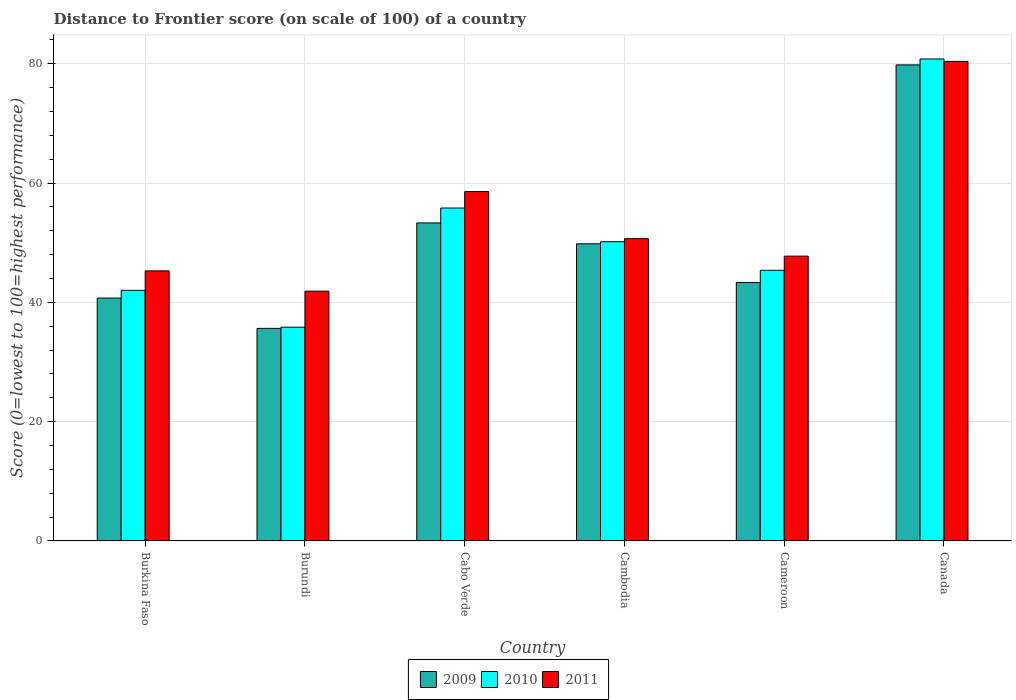How many groups of bars are there?
Your answer should be very brief. 6. Are the number of bars on each tick of the X-axis equal?
Your answer should be very brief. Yes. What is the label of the 1st group of bars from the left?
Keep it short and to the point. Burkina Faso. What is the distance to frontier score of in 2010 in Canada?
Your answer should be very brief. 80.81. Across all countries, what is the maximum distance to frontier score of in 2010?
Your answer should be compact. 80.81. Across all countries, what is the minimum distance to frontier score of in 2009?
Provide a short and direct response. 35.64. In which country was the distance to frontier score of in 2010 minimum?
Provide a succinct answer. Burundi. What is the total distance to frontier score of in 2011 in the graph?
Your answer should be compact. 324.57. What is the difference between the distance to frontier score of in 2011 in Cabo Verde and that in Canada?
Provide a short and direct response. -21.82. What is the difference between the distance to frontier score of in 2009 in Burkina Faso and the distance to frontier score of in 2010 in Cambodia?
Your answer should be compact. -9.45. What is the average distance to frontier score of in 2009 per country?
Your answer should be compact. 50.44. What is the difference between the distance to frontier score of of/in 2011 and distance to frontier score of of/in 2010 in Cabo Verde?
Your answer should be very brief. 2.76. What is the ratio of the distance to frontier score of in 2011 in Burkina Faso to that in Burundi?
Your response must be concise. 1.08. What is the difference between the highest and the second highest distance to frontier score of in 2011?
Your answer should be compact. 21.82. What is the difference between the highest and the lowest distance to frontier score of in 2010?
Your answer should be compact. 44.97. In how many countries, is the distance to frontier score of in 2009 greater than the average distance to frontier score of in 2009 taken over all countries?
Offer a terse response. 2. Is the sum of the distance to frontier score of in 2010 in Burkina Faso and Cameroon greater than the maximum distance to frontier score of in 2011 across all countries?
Make the answer very short. Yes. What does the 3rd bar from the right in Burundi represents?
Your response must be concise. 2009. Are all the bars in the graph horizontal?
Provide a short and direct response. No. What is the difference between two consecutive major ticks on the Y-axis?
Offer a terse response. 20. Are the values on the major ticks of Y-axis written in scientific E-notation?
Offer a terse response. No. Does the graph contain grids?
Keep it short and to the point. Yes. How are the legend labels stacked?
Keep it short and to the point. Horizontal. What is the title of the graph?
Make the answer very short. Distance to Frontier score (on scale of 100) of a country. Does "1992" appear as one of the legend labels in the graph?
Provide a short and direct response. No. What is the label or title of the Y-axis?
Keep it short and to the point. Score (0=lowest to 100=highest performance). What is the Score (0=lowest to 100=highest performance) in 2009 in Burkina Faso?
Your answer should be compact. 40.72. What is the Score (0=lowest to 100=highest performance) of 2010 in Burkina Faso?
Ensure brevity in your answer.  42.02. What is the Score (0=lowest to 100=highest performance) of 2011 in Burkina Faso?
Keep it short and to the point. 45.28. What is the Score (0=lowest to 100=highest performance) in 2009 in Burundi?
Your answer should be very brief. 35.64. What is the Score (0=lowest to 100=highest performance) of 2010 in Burundi?
Your response must be concise. 35.84. What is the Score (0=lowest to 100=highest performance) of 2011 in Burundi?
Offer a terse response. 41.88. What is the Score (0=lowest to 100=highest performance) in 2009 in Cabo Verde?
Give a very brief answer. 53.32. What is the Score (0=lowest to 100=highest performance) of 2010 in Cabo Verde?
Your answer should be very brief. 55.82. What is the Score (0=lowest to 100=highest performance) in 2011 in Cabo Verde?
Your answer should be compact. 58.58. What is the Score (0=lowest to 100=highest performance) of 2009 in Cambodia?
Keep it short and to the point. 49.82. What is the Score (0=lowest to 100=highest performance) of 2010 in Cambodia?
Offer a terse response. 50.17. What is the Score (0=lowest to 100=highest performance) of 2011 in Cambodia?
Your answer should be very brief. 50.68. What is the Score (0=lowest to 100=highest performance) in 2009 in Cameroon?
Provide a succinct answer. 43.33. What is the Score (0=lowest to 100=highest performance) in 2010 in Cameroon?
Ensure brevity in your answer.  45.38. What is the Score (0=lowest to 100=highest performance) in 2011 in Cameroon?
Offer a very short reply. 47.75. What is the Score (0=lowest to 100=highest performance) in 2009 in Canada?
Give a very brief answer. 79.82. What is the Score (0=lowest to 100=highest performance) of 2010 in Canada?
Provide a succinct answer. 80.81. What is the Score (0=lowest to 100=highest performance) in 2011 in Canada?
Provide a short and direct response. 80.4. Across all countries, what is the maximum Score (0=lowest to 100=highest performance) of 2009?
Give a very brief answer. 79.82. Across all countries, what is the maximum Score (0=lowest to 100=highest performance) in 2010?
Your answer should be compact. 80.81. Across all countries, what is the maximum Score (0=lowest to 100=highest performance) in 2011?
Give a very brief answer. 80.4. Across all countries, what is the minimum Score (0=lowest to 100=highest performance) in 2009?
Provide a succinct answer. 35.64. Across all countries, what is the minimum Score (0=lowest to 100=highest performance) in 2010?
Your response must be concise. 35.84. Across all countries, what is the minimum Score (0=lowest to 100=highest performance) in 2011?
Your answer should be very brief. 41.88. What is the total Score (0=lowest to 100=highest performance) in 2009 in the graph?
Give a very brief answer. 302.65. What is the total Score (0=lowest to 100=highest performance) in 2010 in the graph?
Offer a very short reply. 310.04. What is the total Score (0=lowest to 100=highest performance) in 2011 in the graph?
Offer a terse response. 324.57. What is the difference between the Score (0=lowest to 100=highest performance) in 2009 in Burkina Faso and that in Burundi?
Give a very brief answer. 5.08. What is the difference between the Score (0=lowest to 100=highest performance) in 2010 in Burkina Faso and that in Burundi?
Your answer should be very brief. 6.18. What is the difference between the Score (0=lowest to 100=highest performance) of 2009 in Burkina Faso and that in Cambodia?
Keep it short and to the point. -9.1. What is the difference between the Score (0=lowest to 100=highest performance) of 2010 in Burkina Faso and that in Cambodia?
Provide a succinct answer. -8.15. What is the difference between the Score (0=lowest to 100=highest performance) in 2011 in Burkina Faso and that in Cambodia?
Keep it short and to the point. -5.4. What is the difference between the Score (0=lowest to 100=highest performance) in 2009 in Burkina Faso and that in Cameroon?
Ensure brevity in your answer.  -2.61. What is the difference between the Score (0=lowest to 100=highest performance) in 2010 in Burkina Faso and that in Cameroon?
Make the answer very short. -3.36. What is the difference between the Score (0=lowest to 100=highest performance) in 2011 in Burkina Faso and that in Cameroon?
Your answer should be very brief. -2.47. What is the difference between the Score (0=lowest to 100=highest performance) in 2009 in Burkina Faso and that in Canada?
Keep it short and to the point. -39.1. What is the difference between the Score (0=lowest to 100=highest performance) in 2010 in Burkina Faso and that in Canada?
Give a very brief answer. -38.79. What is the difference between the Score (0=lowest to 100=highest performance) in 2011 in Burkina Faso and that in Canada?
Your answer should be compact. -35.12. What is the difference between the Score (0=lowest to 100=highest performance) in 2009 in Burundi and that in Cabo Verde?
Provide a short and direct response. -17.68. What is the difference between the Score (0=lowest to 100=highest performance) in 2010 in Burundi and that in Cabo Verde?
Ensure brevity in your answer.  -19.98. What is the difference between the Score (0=lowest to 100=highest performance) in 2011 in Burundi and that in Cabo Verde?
Your response must be concise. -16.7. What is the difference between the Score (0=lowest to 100=highest performance) of 2009 in Burundi and that in Cambodia?
Ensure brevity in your answer.  -14.18. What is the difference between the Score (0=lowest to 100=highest performance) of 2010 in Burundi and that in Cambodia?
Your answer should be compact. -14.33. What is the difference between the Score (0=lowest to 100=highest performance) of 2011 in Burundi and that in Cambodia?
Your answer should be very brief. -8.8. What is the difference between the Score (0=lowest to 100=highest performance) in 2009 in Burundi and that in Cameroon?
Offer a terse response. -7.69. What is the difference between the Score (0=lowest to 100=highest performance) in 2010 in Burundi and that in Cameroon?
Your answer should be very brief. -9.54. What is the difference between the Score (0=lowest to 100=highest performance) of 2011 in Burundi and that in Cameroon?
Offer a very short reply. -5.87. What is the difference between the Score (0=lowest to 100=highest performance) in 2009 in Burundi and that in Canada?
Give a very brief answer. -44.18. What is the difference between the Score (0=lowest to 100=highest performance) in 2010 in Burundi and that in Canada?
Your response must be concise. -44.97. What is the difference between the Score (0=lowest to 100=highest performance) in 2011 in Burundi and that in Canada?
Give a very brief answer. -38.52. What is the difference between the Score (0=lowest to 100=highest performance) of 2009 in Cabo Verde and that in Cambodia?
Your response must be concise. 3.5. What is the difference between the Score (0=lowest to 100=highest performance) of 2010 in Cabo Verde and that in Cambodia?
Offer a terse response. 5.65. What is the difference between the Score (0=lowest to 100=highest performance) of 2011 in Cabo Verde and that in Cambodia?
Your response must be concise. 7.9. What is the difference between the Score (0=lowest to 100=highest performance) of 2009 in Cabo Verde and that in Cameroon?
Ensure brevity in your answer.  9.99. What is the difference between the Score (0=lowest to 100=highest performance) in 2010 in Cabo Verde and that in Cameroon?
Make the answer very short. 10.44. What is the difference between the Score (0=lowest to 100=highest performance) of 2011 in Cabo Verde and that in Cameroon?
Your response must be concise. 10.83. What is the difference between the Score (0=lowest to 100=highest performance) in 2009 in Cabo Verde and that in Canada?
Your response must be concise. -26.5. What is the difference between the Score (0=lowest to 100=highest performance) in 2010 in Cabo Verde and that in Canada?
Keep it short and to the point. -24.99. What is the difference between the Score (0=lowest to 100=highest performance) of 2011 in Cabo Verde and that in Canada?
Your response must be concise. -21.82. What is the difference between the Score (0=lowest to 100=highest performance) in 2009 in Cambodia and that in Cameroon?
Give a very brief answer. 6.49. What is the difference between the Score (0=lowest to 100=highest performance) in 2010 in Cambodia and that in Cameroon?
Your answer should be very brief. 4.79. What is the difference between the Score (0=lowest to 100=highest performance) in 2011 in Cambodia and that in Cameroon?
Offer a very short reply. 2.93. What is the difference between the Score (0=lowest to 100=highest performance) in 2009 in Cambodia and that in Canada?
Make the answer very short. -30. What is the difference between the Score (0=lowest to 100=highest performance) in 2010 in Cambodia and that in Canada?
Make the answer very short. -30.64. What is the difference between the Score (0=lowest to 100=highest performance) in 2011 in Cambodia and that in Canada?
Offer a very short reply. -29.72. What is the difference between the Score (0=lowest to 100=highest performance) of 2009 in Cameroon and that in Canada?
Offer a terse response. -36.49. What is the difference between the Score (0=lowest to 100=highest performance) in 2010 in Cameroon and that in Canada?
Your answer should be compact. -35.43. What is the difference between the Score (0=lowest to 100=highest performance) of 2011 in Cameroon and that in Canada?
Ensure brevity in your answer.  -32.65. What is the difference between the Score (0=lowest to 100=highest performance) in 2009 in Burkina Faso and the Score (0=lowest to 100=highest performance) in 2010 in Burundi?
Give a very brief answer. 4.88. What is the difference between the Score (0=lowest to 100=highest performance) in 2009 in Burkina Faso and the Score (0=lowest to 100=highest performance) in 2011 in Burundi?
Keep it short and to the point. -1.16. What is the difference between the Score (0=lowest to 100=highest performance) of 2010 in Burkina Faso and the Score (0=lowest to 100=highest performance) of 2011 in Burundi?
Provide a short and direct response. 0.14. What is the difference between the Score (0=lowest to 100=highest performance) in 2009 in Burkina Faso and the Score (0=lowest to 100=highest performance) in 2010 in Cabo Verde?
Offer a very short reply. -15.1. What is the difference between the Score (0=lowest to 100=highest performance) in 2009 in Burkina Faso and the Score (0=lowest to 100=highest performance) in 2011 in Cabo Verde?
Your answer should be very brief. -17.86. What is the difference between the Score (0=lowest to 100=highest performance) in 2010 in Burkina Faso and the Score (0=lowest to 100=highest performance) in 2011 in Cabo Verde?
Offer a terse response. -16.56. What is the difference between the Score (0=lowest to 100=highest performance) in 2009 in Burkina Faso and the Score (0=lowest to 100=highest performance) in 2010 in Cambodia?
Keep it short and to the point. -9.45. What is the difference between the Score (0=lowest to 100=highest performance) of 2009 in Burkina Faso and the Score (0=lowest to 100=highest performance) of 2011 in Cambodia?
Make the answer very short. -9.96. What is the difference between the Score (0=lowest to 100=highest performance) in 2010 in Burkina Faso and the Score (0=lowest to 100=highest performance) in 2011 in Cambodia?
Your answer should be compact. -8.66. What is the difference between the Score (0=lowest to 100=highest performance) in 2009 in Burkina Faso and the Score (0=lowest to 100=highest performance) in 2010 in Cameroon?
Provide a succinct answer. -4.66. What is the difference between the Score (0=lowest to 100=highest performance) in 2009 in Burkina Faso and the Score (0=lowest to 100=highest performance) in 2011 in Cameroon?
Offer a terse response. -7.03. What is the difference between the Score (0=lowest to 100=highest performance) in 2010 in Burkina Faso and the Score (0=lowest to 100=highest performance) in 2011 in Cameroon?
Give a very brief answer. -5.73. What is the difference between the Score (0=lowest to 100=highest performance) of 2009 in Burkina Faso and the Score (0=lowest to 100=highest performance) of 2010 in Canada?
Offer a very short reply. -40.09. What is the difference between the Score (0=lowest to 100=highest performance) of 2009 in Burkina Faso and the Score (0=lowest to 100=highest performance) of 2011 in Canada?
Provide a succinct answer. -39.68. What is the difference between the Score (0=lowest to 100=highest performance) in 2010 in Burkina Faso and the Score (0=lowest to 100=highest performance) in 2011 in Canada?
Ensure brevity in your answer.  -38.38. What is the difference between the Score (0=lowest to 100=highest performance) in 2009 in Burundi and the Score (0=lowest to 100=highest performance) in 2010 in Cabo Verde?
Keep it short and to the point. -20.18. What is the difference between the Score (0=lowest to 100=highest performance) in 2009 in Burundi and the Score (0=lowest to 100=highest performance) in 2011 in Cabo Verde?
Your answer should be very brief. -22.94. What is the difference between the Score (0=lowest to 100=highest performance) of 2010 in Burundi and the Score (0=lowest to 100=highest performance) of 2011 in Cabo Verde?
Your answer should be very brief. -22.74. What is the difference between the Score (0=lowest to 100=highest performance) in 2009 in Burundi and the Score (0=lowest to 100=highest performance) in 2010 in Cambodia?
Make the answer very short. -14.53. What is the difference between the Score (0=lowest to 100=highest performance) in 2009 in Burundi and the Score (0=lowest to 100=highest performance) in 2011 in Cambodia?
Ensure brevity in your answer.  -15.04. What is the difference between the Score (0=lowest to 100=highest performance) in 2010 in Burundi and the Score (0=lowest to 100=highest performance) in 2011 in Cambodia?
Provide a short and direct response. -14.84. What is the difference between the Score (0=lowest to 100=highest performance) of 2009 in Burundi and the Score (0=lowest to 100=highest performance) of 2010 in Cameroon?
Offer a very short reply. -9.74. What is the difference between the Score (0=lowest to 100=highest performance) of 2009 in Burundi and the Score (0=lowest to 100=highest performance) of 2011 in Cameroon?
Your answer should be very brief. -12.11. What is the difference between the Score (0=lowest to 100=highest performance) in 2010 in Burundi and the Score (0=lowest to 100=highest performance) in 2011 in Cameroon?
Offer a very short reply. -11.91. What is the difference between the Score (0=lowest to 100=highest performance) in 2009 in Burundi and the Score (0=lowest to 100=highest performance) in 2010 in Canada?
Give a very brief answer. -45.17. What is the difference between the Score (0=lowest to 100=highest performance) in 2009 in Burundi and the Score (0=lowest to 100=highest performance) in 2011 in Canada?
Keep it short and to the point. -44.76. What is the difference between the Score (0=lowest to 100=highest performance) of 2010 in Burundi and the Score (0=lowest to 100=highest performance) of 2011 in Canada?
Your response must be concise. -44.56. What is the difference between the Score (0=lowest to 100=highest performance) of 2009 in Cabo Verde and the Score (0=lowest to 100=highest performance) of 2010 in Cambodia?
Your response must be concise. 3.15. What is the difference between the Score (0=lowest to 100=highest performance) in 2009 in Cabo Verde and the Score (0=lowest to 100=highest performance) in 2011 in Cambodia?
Give a very brief answer. 2.64. What is the difference between the Score (0=lowest to 100=highest performance) of 2010 in Cabo Verde and the Score (0=lowest to 100=highest performance) of 2011 in Cambodia?
Provide a short and direct response. 5.14. What is the difference between the Score (0=lowest to 100=highest performance) of 2009 in Cabo Verde and the Score (0=lowest to 100=highest performance) of 2010 in Cameroon?
Offer a terse response. 7.94. What is the difference between the Score (0=lowest to 100=highest performance) of 2009 in Cabo Verde and the Score (0=lowest to 100=highest performance) of 2011 in Cameroon?
Make the answer very short. 5.57. What is the difference between the Score (0=lowest to 100=highest performance) in 2010 in Cabo Verde and the Score (0=lowest to 100=highest performance) in 2011 in Cameroon?
Your answer should be very brief. 8.07. What is the difference between the Score (0=lowest to 100=highest performance) in 2009 in Cabo Verde and the Score (0=lowest to 100=highest performance) in 2010 in Canada?
Your response must be concise. -27.49. What is the difference between the Score (0=lowest to 100=highest performance) of 2009 in Cabo Verde and the Score (0=lowest to 100=highest performance) of 2011 in Canada?
Your response must be concise. -27.08. What is the difference between the Score (0=lowest to 100=highest performance) of 2010 in Cabo Verde and the Score (0=lowest to 100=highest performance) of 2011 in Canada?
Give a very brief answer. -24.58. What is the difference between the Score (0=lowest to 100=highest performance) of 2009 in Cambodia and the Score (0=lowest to 100=highest performance) of 2010 in Cameroon?
Your answer should be compact. 4.44. What is the difference between the Score (0=lowest to 100=highest performance) of 2009 in Cambodia and the Score (0=lowest to 100=highest performance) of 2011 in Cameroon?
Your answer should be very brief. 2.07. What is the difference between the Score (0=lowest to 100=highest performance) of 2010 in Cambodia and the Score (0=lowest to 100=highest performance) of 2011 in Cameroon?
Ensure brevity in your answer.  2.42. What is the difference between the Score (0=lowest to 100=highest performance) in 2009 in Cambodia and the Score (0=lowest to 100=highest performance) in 2010 in Canada?
Your answer should be very brief. -30.99. What is the difference between the Score (0=lowest to 100=highest performance) of 2009 in Cambodia and the Score (0=lowest to 100=highest performance) of 2011 in Canada?
Offer a terse response. -30.58. What is the difference between the Score (0=lowest to 100=highest performance) in 2010 in Cambodia and the Score (0=lowest to 100=highest performance) in 2011 in Canada?
Provide a short and direct response. -30.23. What is the difference between the Score (0=lowest to 100=highest performance) of 2009 in Cameroon and the Score (0=lowest to 100=highest performance) of 2010 in Canada?
Your answer should be compact. -37.48. What is the difference between the Score (0=lowest to 100=highest performance) of 2009 in Cameroon and the Score (0=lowest to 100=highest performance) of 2011 in Canada?
Make the answer very short. -37.07. What is the difference between the Score (0=lowest to 100=highest performance) in 2010 in Cameroon and the Score (0=lowest to 100=highest performance) in 2011 in Canada?
Offer a very short reply. -35.02. What is the average Score (0=lowest to 100=highest performance) in 2009 per country?
Your response must be concise. 50.44. What is the average Score (0=lowest to 100=highest performance) in 2010 per country?
Ensure brevity in your answer.  51.67. What is the average Score (0=lowest to 100=highest performance) of 2011 per country?
Your answer should be compact. 54.09. What is the difference between the Score (0=lowest to 100=highest performance) of 2009 and Score (0=lowest to 100=highest performance) of 2011 in Burkina Faso?
Give a very brief answer. -4.56. What is the difference between the Score (0=lowest to 100=highest performance) of 2010 and Score (0=lowest to 100=highest performance) of 2011 in Burkina Faso?
Provide a succinct answer. -3.26. What is the difference between the Score (0=lowest to 100=highest performance) in 2009 and Score (0=lowest to 100=highest performance) in 2011 in Burundi?
Offer a terse response. -6.24. What is the difference between the Score (0=lowest to 100=highest performance) of 2010 and Score (0=lowest to 100=highest performance) of 2011 in Burundi?
Make the answer very short. -6.04. What is the difference between the Score (0=lowest to 100=highest performance) of 2009 and Score (0=lowest to 100=highest performance) of 2011 in Cabo Verde?
Your answer should be very brief. -5.26. What is the difference between the Score (0=lowest to 100=highest performance) of 2010 and Score (0=lowest to 100=highest performance) of 2011 in Cabo Verde?
Give a very brief answer. -2.76. What is the difference between the Score (0=lowest to 100=highest performance) of 2009 and Score (0=lowest to 100=highest performance) of 2010 in Cambodia?
Provide a short and direct response. -0.35. What is the difference between the Score (0=lowest to 100=highest performance) in 2009 and Score (0=lowest to 100=highest performance) in 2011 in Cambodia?
Your response must be concise. -0.86. What is the difference between the Score (0=lowest to 100=highest performance) in 2010 and Score (0=lowest to 100=highest performance) in 2011 in Cambodia?
Give a very brief answer. -0.51. What is the difference between the Score (0=lowest to 100=highest performance) of 2009 and Score (0=lowest to 100=highest performance) of 2010 in Cameroon?
Provide a short and direct response. -2.05. What is the difference between the Score (0=lowest to 100=highest performance) in 2009 and Score (0=lowest to 100=highest performance) in 2011 in Cameroon?
Ensure brevity in your answer.  -4.42. What is the difference between the Score (0=lowest to 100=highest performance) of 2010 and Score (0=lowest to 100=highest performance) of 2011 in Cameroon?
Give a very brief answer. -2.37. What is the difference between the Score (0=lowest to 100=highest performance) in 2009 and Score (0=lowest to 100=highest performance) in 2010 in Canada?
Your response must be concise. -0.99. What is the difference between the Score (0=lowest to 100=highest performance) in 2009 and Score (0=lowest to 100=highest performance) in 2011 in Canada?
Your answer should be very brief. -0.58. What is the difference between the Score (0=lowest to 100=highest performance) of 2010 and Score (0=lowest to 100=highest performance) of 2011 in Canada?
Ensure brevity in your answer.  0.41. What is the ratio of the Score (0=lowest to 100=highest performance) of 2009 in Burkina Faso to that in Burundi?
Offer a terse response. 1.14. What is the ratio of the Score (0=lowest to 100=highest performance) in 2010 in Burkina Faso to that in Burundi?
Your answer should be very brief. 1.17. What is the ratio of the Score (0=lowest to 100=highest performance) in 2011 in Burkina Faso to that in Burundi?
Offer a terse response. 1.08. What is the ratio of the Score (0=lowest to 100=highest performance) in 2009 in Burkina Faso to that in Cabo Verde?
Ensure brevity in your answer.  0.76. What is the ratio of the Score (0=lowest to 100=highest performance) in 2010 in Burkina Faso to that in Cabo Verde?
Your answer should be very brief. 0.75. What is the ratio of the Score (0=lowest to 100=highest performance) of 2011 in Burkina Faso to that in Cabo Verde?
Keep it short and to the point. 0.77. What is the ratio of the Score (0=lowest to 100=highest performance) in 2009 in Burkina Faso to that in Cambodia?
Offer a terse response. 0.82. What is the ratio of the Score (0=lowest to 100=highest performance) in 2010 in Burkina Faso to that in Cambodia?
Provide a succinct answer. 0.84. What is the ratio of the Score (0=lowest to 100=highest performance) of 2011 in Burkina Faso to that in Cambodia?
Provide a short and direct response. 0.89. What is the ratio of the Score (0=lowest to 100=highest performance) in 2009 in Burkina Faso to that in Cameroon?
Your answer should be compact. 0.94. What is the ratio of the Score (0=lowest to 100=highest performance) in 2010 in Burkina Faso to that in Cameroon?
Your answer should be very brief. 0.93. What is the ratio of the Score (0=lowest to 100=highest performance) of 2011 in Burkina Faso to that in Cameroon?
Keep it short and to the point. 0.95. What is the ratio of the Score (0=lowest to 100=highest performance) in 2009 in Burkina Faso to that in Canada?
Your response must be concise. 0.51. What is the ratio of the Score (0=lowest to 100=highest performance) in 2010 in Burkina Faso to that in Canada?
Give a very brief answer. 0.52. What is the ratio of the Score (0=lowest to 100=highest performance) in 2011 in Burkina Faso to that in Canada?
Your response must be concise. 0.56. What is the ratio of the Score (0=lowest to 100=highest performance) of 2009 in Burundi to that in Cabo Verde?
Ensure brevity in your answer.  0.67. What is the ratio of the Score (0=lowest to 100=highest performance) of 2010 in Burundi to that in Cabo Verde?
Your answer should be compact. 0.64. What is the ratio of the Score (0=lowest to 100=highest performance) in 2011 in Burundi to that in Cabo Verde?
Provide a short and direct response. 0.71. What is the ratio of the Score (0=lowest to 100=highest performance) in 2009 in Burundi to that in Cambodia?
Your response must be concise. 0.72. What is the ratio of the Score (0=lowest to 100=highest performance) in 2010 in Burundi to that in Cambodia?
Offer a terse response. 0.71. What is the ratio of the Score (0=lowest to 100=highest performance) of 2011 in Burundi to that in Cambodia?
Offer a terse response. 0.83. What is the ratio of the Score (0=lowest to 100=highest performance) of 2009 in Burundi to that in Cameroon?
Give a very brief answer. 0.82. What is the ratio of the Score (0=lowest to 100=highest performance) of 2010 in Burundi to that in Cameroon?
Provide a short and direct response. 0.79. What is the ratio of the Score (0=lowest to 100=highest performance) in 2011 in Burundi to that in Cameroon?
Provide a short and direct response. 0.88. What is the ratio of the Score (0=lowest to 100=highest performance) in 2009 in Burundi to that in Canada?
Offer a very short reply. 0.45. What is the ratio of the Score (0=lowest to 100=highest performance) of 2010 in Burundi to that in Canada?
Keep it short and to the point. 0.44. What is the ratio of the Score (0=lowest to 100=highest performance) of 2011 in Burundi to that in Canada?
Give a very brief answer. 0.52. What is the ratio of the Score (0=lowest to 100=highest performance) in 2009 in Cabo Verde to that in Cambodia?
Make the answer very short. 1.07. What is the ratio of the Score (0=lowest to 100=highest performance) in 2010 in Cabo Verde to that in Cambodia?
Provide a short and direct response. 1.11. What is the ratio of the Score (0=lowest to 100=highest performance) of 2011 in Cabo Verde to that in Cambodia?
Provide a short and direct response. 1.16. What is the ratio of the Score (0=lowest to 100=highest performance) of 2009 in Cabo Verde to that in Cameroon?
Give a very brief answer. 1.23. What is the ratio of the Score (0=lowest to 100=highest performance) in 2010 in Cabo Verde to that in Cameroon?
Your answer should be compact. 1.23. What is the ratio of the Score (0=lowest to 100=highest performance) in 2011 in Cabo Verde to that in Cameroon?
Provide a short and direct response. 1.23. What is the ratio of the Score (0=lowest to 100=highest performance) in 2009 in Cabo Verde to that in Canada?
Your response must be concise. 0.67. What is the ratio of the Score (0=lowest to 100=highest performance) of 2010 in Cabo Verde to that in Canada?
Offer a very short reply. 0.69. What is the ratio of the Score (0=lowest to 100=highest performance) of 2011 in Cabo Verde to that in Canada?
Your answer should be compact. 0.73. What is the ratio of the Score (0=lowest to 100=highest performance) of 2009 in Cambodia to that in Cameroon?
Provide a short and direct response. 1.15. What is the ratio of the Score (0=lowest to 100=highest performance) in 2010 in Cambodia to that in Cameroon?
Provide a succinct answer. 1.11. What is the ratio of the Score (0=lowest to 100=highest performance) of 2011 in Cambodia to that in Cameroon?
Make the answer very short. 1.06. What is the ratio of the Score (0=lowest to 100=highest performance) in 2009 in Cambodia to that in Canada?
Your response must be concise. 0.62. What is the ratio of the Score (0=lowest to 100=highest performance) in 2010 in Cambodia to that in Canada?
Your response must be concise. 0.62. What is the ratio of the Score (0=lowest to 100=highest performance) of 2011 in Cambodia to that in Canada?
Your response must be concise. 0.63. What is the ratio of the Score (0=lowest to 100=highest performance) of 2009 in Cameroon to that in Canada?
Keep it short and to the point. 0.54. What is the ratio of the Score (0=lowest to 100=highest performance) of 2010 in Cameroon to that in Canada?
Keep it short and to the point. 0.56. What is the ratio of the Score (0=lowest to 100=highest performance) of 2011 in Cameroon to that in Canada?
Ensure brevity in your answer.  0.59. What is the difference between the highest and the second highest Score (0=lowest to 100=highest performance) in 2010?
Provide a short and direct response. 24.99. What is the difference between the highest and the second highest Score (0=lowest to 100=highest performance) in 2011?
Your answer should be very brief. 21.82. What is the difference between the highest and the lowest Score (0=lowest to 100=highest performance) in 2009?
Your answer should be very brief. 44.18. What is the difference between the highest and the lowest Score (0=lowest to 100=highest performance) in 2010?
Your response must be concise. 44.97. What is the difference between the highest and the lowest Score (0=lowest to 100=highest performance) in 2011?
Your answer should be compact. 38.52. 